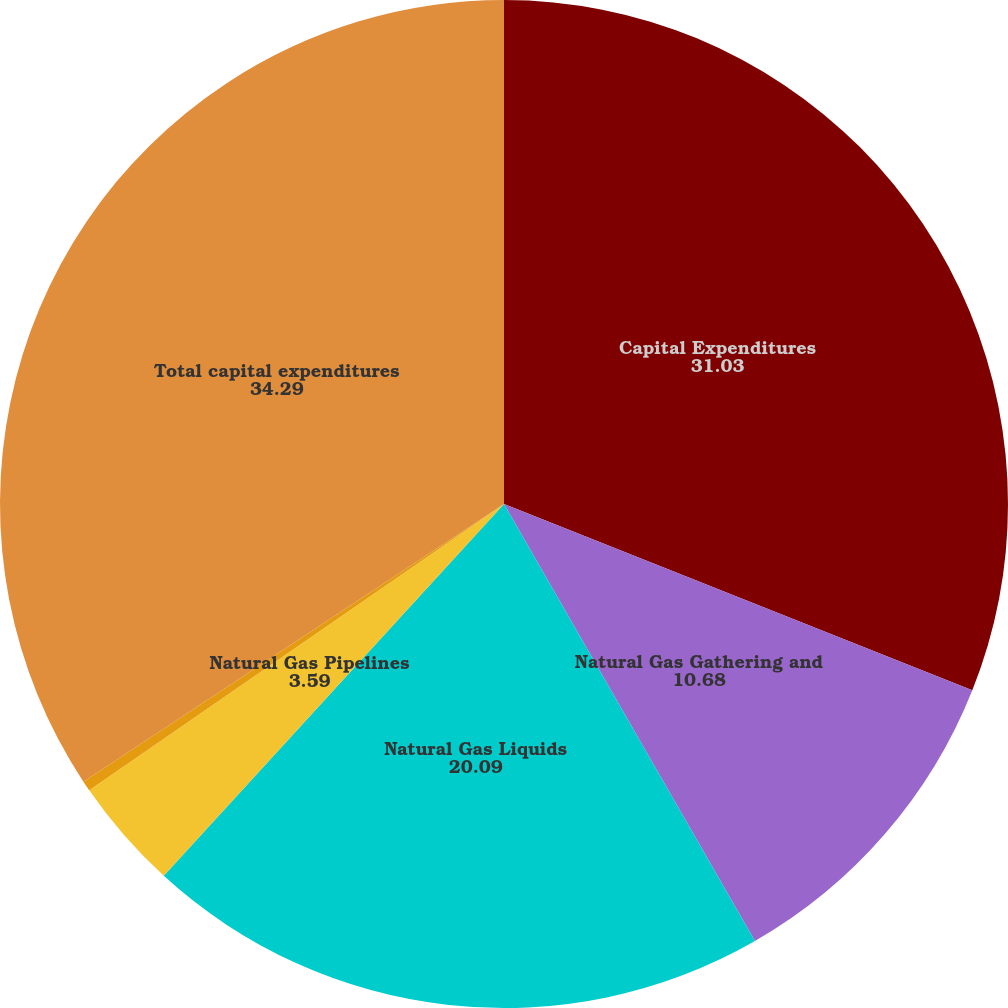Convert chart. <chart><loc_0><loc_0><loc_500><loc_500><pie_chart><fcel>Capital Expenditures<fcel>Natural Gas Gathering and<fcel>Natural Gas Liquids<fcel>Natural Gas Pipelines<fcel>Other<fcel>Total capital expenditures<nl><fcel>31.03%<fcel>10.68%<fcel>20.09%<fcel>3.59%<fcel>0.33%<fcel>34.29%<nl></chart> 